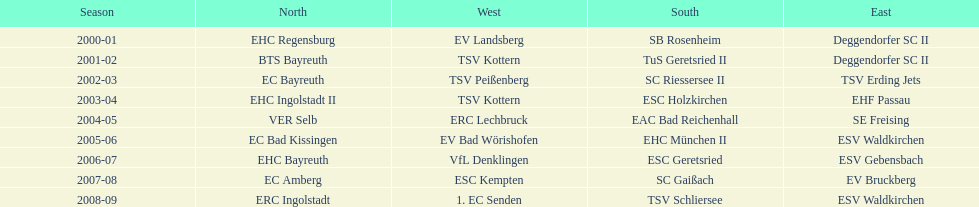What is the number of times deggendorfer sc ii is on the list? 2. 